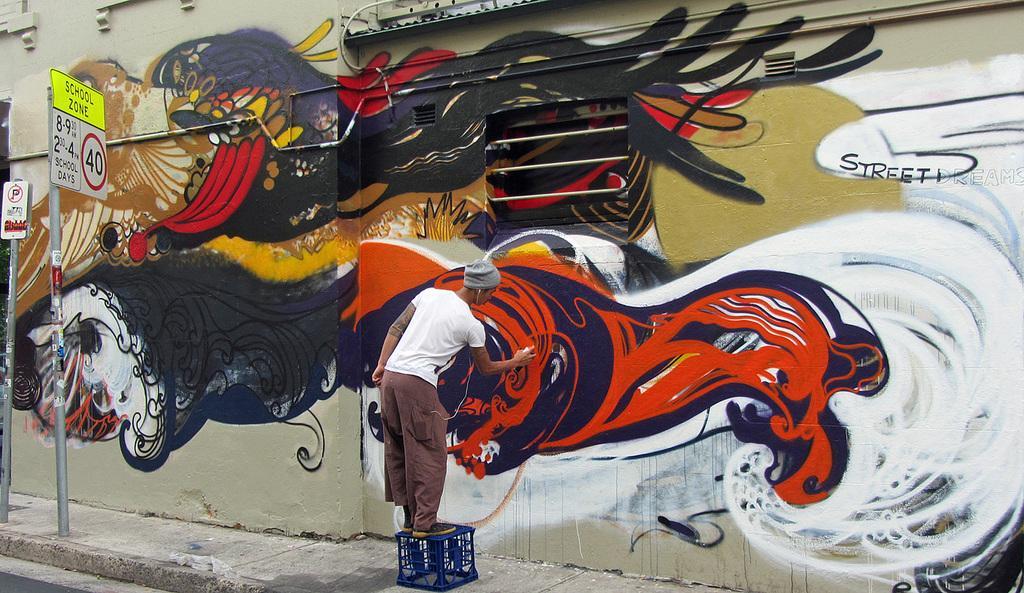In one or two sentences, can you explain what this image depicts? In this image we can see a person painting on the wall, he is standing on the box, there are some boards with some text on it, also we can see graffiti on the wall, there are text on the wall. 